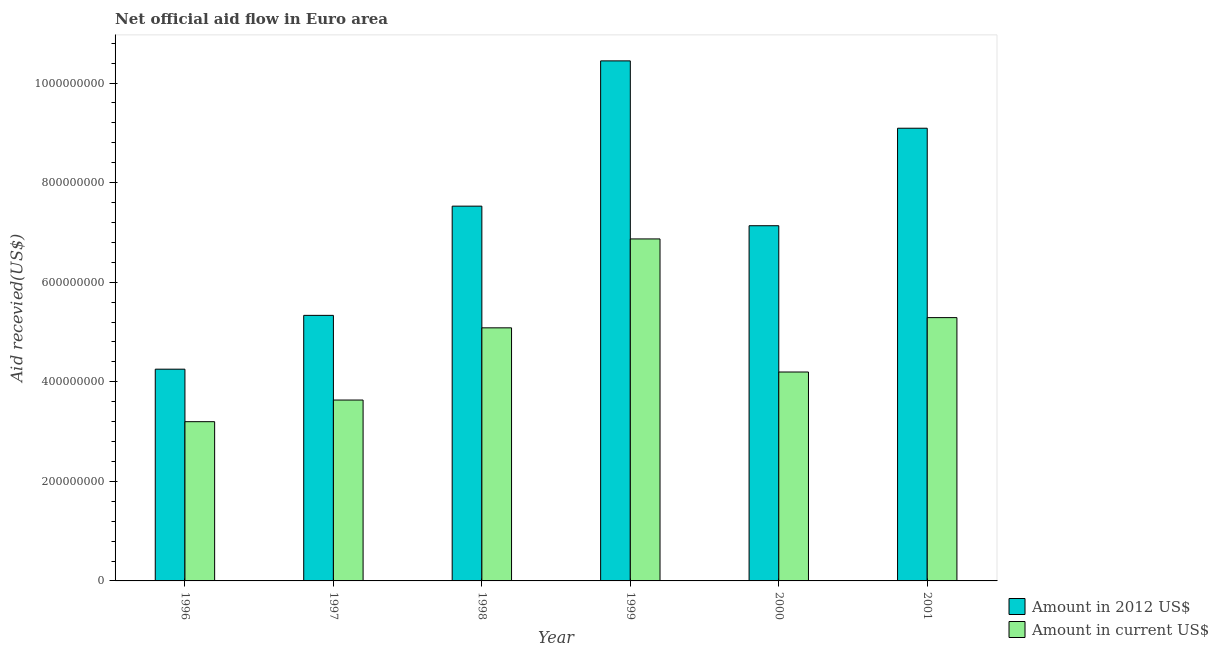How many different coloured bars are there?
Give a very brief answer. 2. How many groups of bars are there?
Keep it short and to the point. 6. Are the number of bars per tick equal to the number of legend labels?
Provide a short and direct response. Yes. Are the number of bars on each tick of the X-axis equal?
Offer a very short reply. Yes. How many bars are there on the 3rd tick from the left?
Ensure brevity in your answer.  2. How many bars are there on the 1st tick from the right?
Make the answer very short. 2. What is the label of the 5th group of bars from the left?
Your response must be concise. 2000. In how many cases, is the number of bars for a given year not equal to the number of legend labels?
Offer a terse response. 0. What is the amount of aid received(expressed in 2012 us$) in 2000?
Provide a short and direct response. 7.13e+08. Across all years, what is the maximum amount of aid received(expressed in us$)?
Provide a succinct answer. 6.87e+08. Across all years, what is the minimum amount of aid received(expressed in 2012 us$)?
Your answer should be very brief. 4.25e+08. What is the total amount of aid received(expressed in us$) in the graph?
Your response must be concise. 2.83e+09. What is the difference between the amount of aid received(expressed in us$) in 1996 and that in 2001?
Provide a short and direct response. -2.09e+08. What is the difference between the amount of aid received(expressed in us$) in 1996 and the amount of aid received(expressed in 2012 us$) in 1998?
Offer a very short reply. -1.88e+08. What is the average amount of aid received(expressed in us$) per year?
Your answer should be compact. 4.71e+08. In how many years, is the amount of aid received(expressed in 2012 us$) greater than 200000000 US$?
Make the answer very short. 6. What is the ratio of the amount of aid received(expressed in 2012 us$) in 2000 to that in 2001?
Your response must be concise. 0.78. Is the amount of aid received(expressed in 2012 us$) in 1998 less than that in 2000?
Give a very brief answer. No. What is the difference between the highest and the second highest amount of aid received(expressed in us$)?
Keep it short and to the point. 1.58e+08. What is the difference between the highest and the lowest amount of aid received(expressed in us$)?
Give a very brief answer. 3.67e+08. Is the sum of the amount of aid received(expressed in us$) in 1998 and 2001 greater than the maximum amount of aid received(expressed in 2012 us$) across all years?
Keep it short and to the point. Yes. What does the 2nd bar from the left in 1996 represents?
Your response must be concise. Amount in current US$. What does the 1st bar from the right in 1998 represents?
Provide a short and direct response. Amount in current US$. Are all the bars in the graph horizontal?
Ensure brevity in your answer.  No. What is the difference between two consecutive major ticks on the Y-axis?
Ensure brevity in your answer.  2.00e+08. Does the graph contain any zero values?
Provide a succinct answer. No. How are the legend labels stacked?
Ensure brevity in your answer.  Vertical. What is the title of the graph?
Your answer should be very brief. Net official aid flow in Euro area. Does "National Visitors" appear as one of the legend labels in the graph?
Provide a short and direct response. No. What is the label or title of the X-axis?
Offer a terse response. Year. What is the label or title of the Y-axis?
Give a very brief answer. Aid recevied(US$). What is the Aid recevied(US$) of Amount in 2012 US$ in 1996?
Your response must be concise. 4.25e+08. What is the Aid recevied(US$) of Amount in current US$ in 1996?
Make the answer very short. 3.20e+08. What is the Aid recevied(US$) in Amount in 2012 US$ in 1997?
Your answer should be compact. 5.33e+08. What is the Aid recevied(US$) in Amount in current US$ in 1997?
Your answer should be very brief. 3.63e+08. What is the Aid recevied(US$) of Amount in 2012 US$ in 1998?
Your answer should be compact. 7.53e+08. What is the Aid recevied(US$) in Amount in current US$ in 1998?
Keep it short and to the point. 5.08e+08. What is the Aid recevied(US$) of Amount in 2012 US$ in 1999?
Provide a short and direct response. 1.04e+09. What is the Aid recevied(US$) of Amount in current US$ in 1999?
Offer a terse response. 6.87e+08. What is the Aid recevied(US$) in Amount in 2012 US$ in 2000?
Offer a terse response. 7.13e+08. What is the Aid recevied(US$) in Amount in current US$ in 2000?
Your response must be concise. 4.20e+08. What is the Aid recevied(US$) of Amount in 2012 US$ in 2001?
Offer a terse response. 9.09e+08. What is the Aid recevied(US$) in Amount in current US$ in 2001?
Your response must be concise. 5.29e+08. Across all years, what is the maximum Aid recevied(US$) of Amount in 2012 US$?
Provide a succinct answer. 1.04e+09. Across all years, what is the maximum Aid recevied(US$) in Amount in current US$?
Make the answer very short. 6.87e+08. Across all years, what is the minimum Aid recevied(US$) of Amount in 2012 US$?
Offer a terse response. 4.25e+08. Across all years, what is the minimum Aid recevied(US$) in Amount in current US$?
Your response must be concise. 3.20e+08. What is the total Aid recevied(US$) in Amount in 2012 US$ in the graph?
Offer a terse response. 4.38e+09. What is the total Aid recevied(US$) of Amount in current US$ in the graph?
Your answer should be compact. 2.83e+09. What is the difference between the Aid recevied(US$) of Amount in 2012 US$ in 1996 and that in 1997?
Your response must be concise. -1.08e+08. What is the difference between the Aid recevied(US$) in Amount in current US$ in 1996 and that in 1997?
Offer a terse response. -4.35e+07. What is the difference between the Aid recevied(US$) of Amount in 2012 US$ in 1996 and that in 1998?
Keep it short and to the point. -3.27e+08. What is the difference between the Aid recevied(US$) of Amount in current US$ in 1996 and that in 1998?
Provide a succinct answer. -1.88e+08. What is the difference between the Aid recevied(US$) of Amount in 2012 US$ in 1996 and that in 1999?
Your response must be concise. -6.19e+08. What is the difference between the Aid recevied(US$) of Amount in current US$ in 1996 and that in 1999?
Ensure brevity in your answer.  -3.67e+08. What is the difference between the Aid recevied(US$) of Amount in 2012 US$ in 1996 and that in 2000?
Provide a succinct answer. -2.88e+08. What is the difference between the Aid recevied(US$) of Amount in current US$ in 1996 and that in 2000?
Offer a very short reply. -9.98e+07. What is the difference between the Aid recevied(US$) of Amount in 2012 US$ in 1996 and that in 2001?
Provide a short and direct response. -4.84e+08. What is the difference between the Aid recevied(US$) of Amount in current US$ in 1996 and that in 2001?
Ensure brevity in your answer.  -2.09e+08. What is the difference between the Aid recevied(US$) in Amount in 2012 US$ in 1997 and that in 1998?
Offer a terse response. -2.19e+08. What is the difference between the Aid recevied(US$) in Amount in current US$ in 1997 and that in 1998?
Give a very brief answer. -1.45e+08. What is the difference between the Aid recevied(US$) of Amount in 2012 US$ in 1997 and that in 1999?
Offer a terse response. -5.11e+08. What is the difference between the Aid recevied(US$) of Amount in current US$ in 1997 and that in 1999?
Offer a terse response. -3.24e+08. What is the difference between the Aid recevied(US$) in Amount in 2012 US$ in 1997 and that in 2000?
Your answer should be compact. -1.80e+08. What is the difference between the Aid recevied(US$) in Amount in current US$ in 1997 and that in 2000?
Keep it short and to the point. -5.63e+07. What is the difference between the Aid recevied(US$) in Amount in 2012 US$ in 1997 and that in 2001?
Your answer should be compact. -3.76e+08. What is the difference between the Aid recevied(US$) in Amount in current US$ in 1997 and that in 2001?
Provide a succinct answer. -1.66e+08. What is the difference between the Aid recevied(US$) of Amount in 2012 US$ in 1998 and that in 1999?
Provide a short and direct response. -2.92e+08. What is the difference between the Aid recevied(US$) of Amount in current US$ in 1998 and that in 1999?
Make the answer very short. -1.79e+08. What is the difference between the Aid recevied(US$) of Amount in 2012 US$ in 1998 and that in 2000?
Your response must be concise. 3.93e+07. What is the difference between the Aid recevied(US$) in Amount in current US$ in 1998 and that in 2000?
Your response must be concise. 8.87e+07. What is the difference between the Aid recevied(US$) of Amount in 2012 US$ in 1998 and that in 2001?
Provide a short and direct response. -1.57e+08. What is the difference between the Aid recevied(US$) of Amount in current US$ in 1998 and that in 2001?
Offer a very short reply. -2.05e+07. What is the difference between the Aid recevied(US$) of Amount in 2012 US$ in 1999 and that in 2000?
Offer a terse response. 3.31e+08. What is the difference between the Aid recevied(US$) of Amount in current US$ in 1999 and that in 2000?
Your response must be concise. 2.67e+08. What is the difference between the Aid recevied(US$) of Amount in 2012 US$ in 1999 and that in 2001?
Your response must be concise. 1.35e+08. What is the difference between the Aid recevied(US$) in Amount in current US$ in 1999 and that in 2001?
Ensure brevity in your answer.  1.58e+08. What is the difference between the Aid recevied(US$) in Amount in 2012 US$ in 2000 and that in 2001?
Make the answer very short. -1.96e+08. What is the difference between the Aid recevied(US$) in Amount in current US$ in 2000 and that in 2001?
Your response must be concise. -1.09e+08. What is the difference between the Aid recevied(US$) in Amount in 2012 US$ in 1996 and the Aid recevied(US$) in Amount in current US$ in 1997?
Offer a very short reply. 6.20e+07. What is the difference between the Aid recevied(US$) in Amount in 2012 US$ in 1996 and the Aid recevied(US$) in Amount in current US$ in 1998?
Your response must be concise. -8.30e+07. What is the difference between the Aid recevied(US$) of Amount in 2012 US$ in 1996 and the Aid recevied(US$) of Amount in current US$ in 1999?
Offer a very short reply. -2.62e+08. What is the difference between the Aid recevied(US$) in Amount in 2012 US$ in 1996 and the Aid recevied(US$) in Amount in current US$ in 2000?
Offer a terse response. 5.69e+06. What is the difference between the Aid recevied(US$) of Amount in 2012 US$ in 1996 and the Aid recevied(US$) of Amount in current US$ in 2001?
Your answer should be compact. -1.04e+08. What is the difference between the Aid recevied(US$) in Amount in 2012 US$ in 1997 and the Aid recevied(US$) in Amount in current US$ in 1998?
Keep it short and to the point. 2.50e+07. What is the difference between the Aid recevied(US$) of Amount in 2012 US$ in 1997 and the Aid recevied(US$) of Amount in current US$ in 1999?
Provide a short and direct response. -1.54e+08. What is the difference between the Aid recevied(US$) in Amount in 2012 US$ in 1997 and the Aid recevied(US$) in Amount in current US$ in 2000?
Give a very brief answer. 1.14e+08. What is the difference between the Aid recevied(US$) in Amount in 2012 US$ in 1997 and the Aid recevied(US$) in Amount in current US$ in 2001?
Your answer should be compact. 4.52e+06. What is the difference between the Aid recevied(US$) in Amount in 2012 US$ in 1998 and the Aid recevied(US$) in Amount in current US$ in 1999?
Offer a terse response. 6.58e+07. What is the difference between the Aid recevied(US$) of Amount in 2012 US$ in 1998 and the Aid recevied(US$) of Amount in current US$ in 2000?
Make the answer very short. 3.33e+08. What is the difference between the Aid recevied(US$) in Amount in 2012 US$ in 1998 and the Aid recevied(US$) in Amount in current US$ in 2001?
Make the answer very short. 2.24e+08. What is the difference between the Aid recevied(US$) in Amount in 2012 US$ in 1999 and the Aid recevied(US$) in Amount in current US$ in 2000?
Provide a succinct answer. 6.25e+08. What is the difference between the Aid recevied(US$) in Amount in 2012 US$ in 1999 and the Aid recevied(US$) in Amount in current US$ in 2001?
Make the answer very short. 5.16e+08. What is the difference between the Aid recevied(US$) in Amount in 2012 US$ in 2000 and the Aid recevied(US$) in Amount in current US$ in 2001?
Keep it short and to the point. 1.85e+08. What is the average Aid recevied(US$) of Amount in 2012 US$ per year?
Give a very brief answer. 7.30e+08. What is the average Aid recevied(US$) in Amount in current US$ per year?
Your response must be concise. 4.71e+08. In the year 1996, what is the difference between the Aid recevied(US$) of Amount in 2012 US$ and Aid recevied(US$) of Amount in current US$?
Provide a succinct answer. 1.05e+08. In the year 1997, what is the difference between the Aid recevied(US$) of Amount in 2012 US$ and Aid recevied(US$) of Amount in current US$?
Your answer should be very brief. 1.70e+08. In the year 1998, what is the difference between the Aid recevied(US$) in Amount in 2012 US$ and Aid recevied(US$) in Amount in current US$?
Provide a succinct answer. 2.44e+08. In the year 1999, what is the difference between the Aid recevied(US$) of Amount in 2012 US$ and Aid recevied(US$) of Amount in current US$?
Ensure brevity in your answer.  3.58e+08. In the year 2000, what is the difference between the Aid recevied(US$) of Amount in 2012 US$ and Aid recevied(US$) of Amount in current US$?
Make the answer very short. 2.94e+08. In the year 2001, what is the difference between the Aid recevied(US$) in Amount in 2012 US$ and Aid recevied(US$) in Amount in current US$?
Offer a very short reply. 3.80e+08. What is the ratio of the Aid recevied(US$) in Amount in 2012 US$ in 1996 to that in 1997?
Your response must be concise. 0.8. What is the ratio of the Aid recevied(US$) in Amount in current US$ in 1996 to that in 1997?
Your answer should be very brief. 0.88. What is the ratio of the Aid recevied(US$) of Amount in 2012 US$ in 1996 to that in 1998?
Ensure brevity in your answer.  0.56. What is the ratio of the Aid recevied(US$) in Amount in current US$ in 1996 to that in 1998?
Your response must be concise. 0.63. What is the ratio of the Aid recevied(US$) of Amount in 2012 US$ in 1996 to that in 1999?
Ensure brevity in your answer.  0.41. What is the ratio of the Aid recevied(US$) of Amount in current US$ in 1996 to that in 1999?
Keep it short and to the point. 0.47. What is the ratio of the Aid recevied(US$) in Amount in 2012 US$ in 1996 to that in 2000?
Ensure brevity in your answer.  0.6. What is the ratio of the Aid recevied(US$) of Amount in current US$ in 1996 to that in 2000?
Provide a short and direct response. 0.76. What is the ratio of the Aid recevied(US$) in Amount in 2012 US$ in 1996 to that in 2001?
Provide a short and direct response. 0.47. What is the ratio of the Aid recevied(US$) in Amount in current US$ in 1996 to that in 2001?
Your answer should be compact. 0.6. What is the ratio of the Aid recevied(US$) in Amount in 2012 US$ in 1997 to that in 1998?
Make the answer very short. 0.71. What is the ratio of the Aid recevied(US$) of Amount in current US$ in 1997 to that in 1998?
Provide a short and direct response. 0.71. What is the ratio of the Aid recevied(US$) in Amount in 2012 US$ in 1997 to that in 1999?
Make the answer very short. 0.51. What is the ratio of the Aid recevied(US$) in Amount in current US$ in 1997 to that in 1999?
Offer a terse response. 0.53. What is the ratio of the Aid recevied(US$) in Amount in 2012 US$ in 1997 to that in 2000?
Your answer should be compact. 0.75. What is the ratio of the Aid recevied(US$) in Amount in current US$ in 1997 to that in 2000?
Ensure brevity in your answer.  0.87. What is the ratio of the Aid recevied(US$) of Amount in 2012 US$ in 1997 to that in 2001?
Offer a terse response. 0.59. What is the ratio of the Aid recevied(US$) of Amount in current US$ in 1997 to that in 2001?
Ensure brevity in your answer.  0.69. What is the ratio of the Aid recevied(US$) in Amount in 2012 US$ in 1998 to that in 1999?
Your answer should be very brief. 0.72. What is the ratio of the Aid recevied(US$) in Amount in current US$ in 1998 to that in 1999?
Offer a terse response. 0.74. What is the ratio of the Aid recevied(US$) of Amount in 2012 US$ in 1998 to that in 2000?
Make the answer very short. 1.06. What is the ratio of the Aid recevied(US$) of Amount in current US$ in 1998 to that in 2000?
Give a very brief answer. 1.21. What is the ratio of the Aid recevied(US$) of Amount in 2012 US$ in 1998 to that in 2001?
Offer a terse response. 0.83. What is the ratio of the Aid recevied(US$) of Amount in current US$ in 1998 to that in 2001?
Your response must be concise. 0.96. What is the ratio of the Aid recevied(US$) of Amount in 2012 US$ in 1999 to that in 2000?
Ensure brevity in your answer.  1.46. What is the ratio of the Aid recevied(US$) of Amount in current US$ in 1999 to that in 2000?
Keep it short and to the point. 1.64. What is the ratio of the Aid recevied(US$) in Amount in 2012 US$ in 1999 to that in 2001?
Your response must be concise. 1.15. What is the ratio of the Aid recevied(US$) in Amount in current US$ in 1999 to that in 2001?
Your answer should be very brief. 1.3. What is the ratio of the Aid recevied(US$) in Amount in 2012 US$ in 2000 to that in 2001?
Offer a very short reply. 0.78. What is the ratio of the Aid recevied(US$) of Amount in current US$ in 2000 to that in 2001?
Your answer should be compact. 0.79. What is the difference between the highest and the second highest Aid recevied(US$) in Amount in 2012 US$?
Your answer should be very brief. 1.35e+08. What is the difference between the highest and the second highest Aid recevied(US$) in Amount in current US$?
Your answer should be compact. 1.58e+08. What is the difference between the highest and the lowest Aid recevied(US$) in Amount in 2012 US$?
Your answer should be very brief. 6.19e+08. What is the difference between the highest and the lowest Aid recevied(US$) of Amount in current US$?
Offer a very short reply. 3.67e+08. 